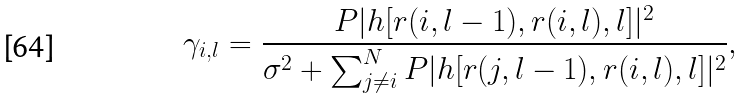Convert formula to latex. <formula><loc_0><loc_0><loc_500><loc_500>\gamma _ { i , l } = \frac { P | h [ r ( i , l - 1 ) , r ( i , l ) , l ] | ^ { 2 } } { \sigma ^ { 2 } + \sum _ { j \neq i } ^ { N } P | h [ r ( j , l - 1 ) , r ( i , l ) , l ] | ^ { 2 } } ,</formula> 